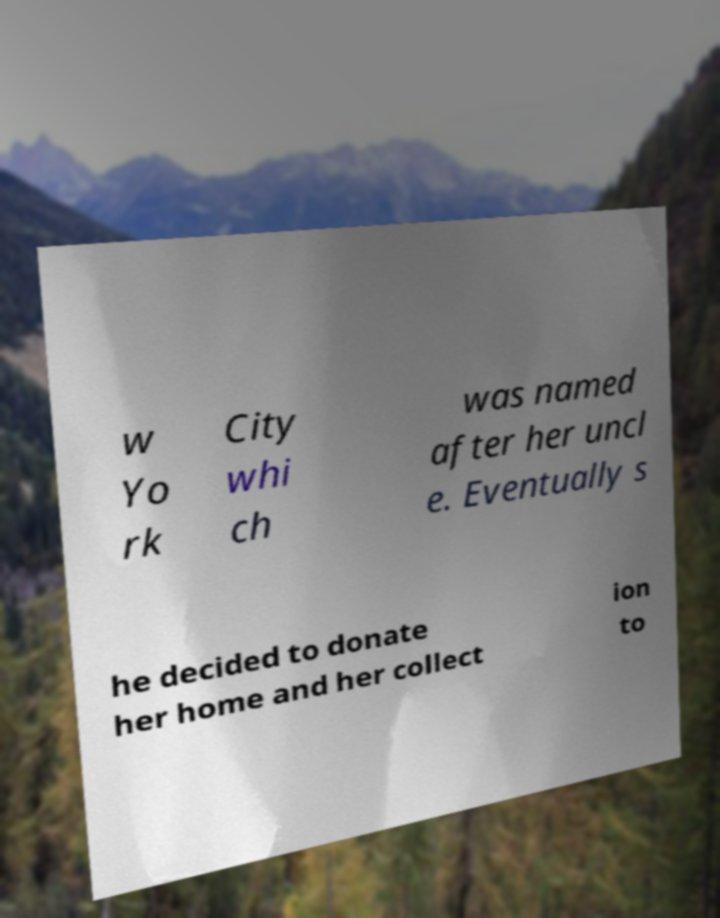For documentation purposes, I need the text within this image transcribed. Could you provide that? w Yo rk City whi ch was named after her uncl e. Eventually s he decided to donate her home and her collect ion to 